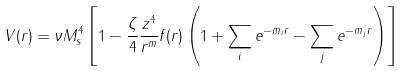<formula> <loc_0><loc_0><loc_500><loc_500>V ( r ) = \nu M _ { s } ^ { 4 } \left [ 1 - \frac { \zeta } { 4 } \frac { z ^ { 4 } } { r ^ { m } } f ( r ) \left ( 1 + \sum _ { i } e ^ { - m _ { i } r } - \sum _ { j } e ^ { - m _ { j } r } \right ) \right ]</formula> 